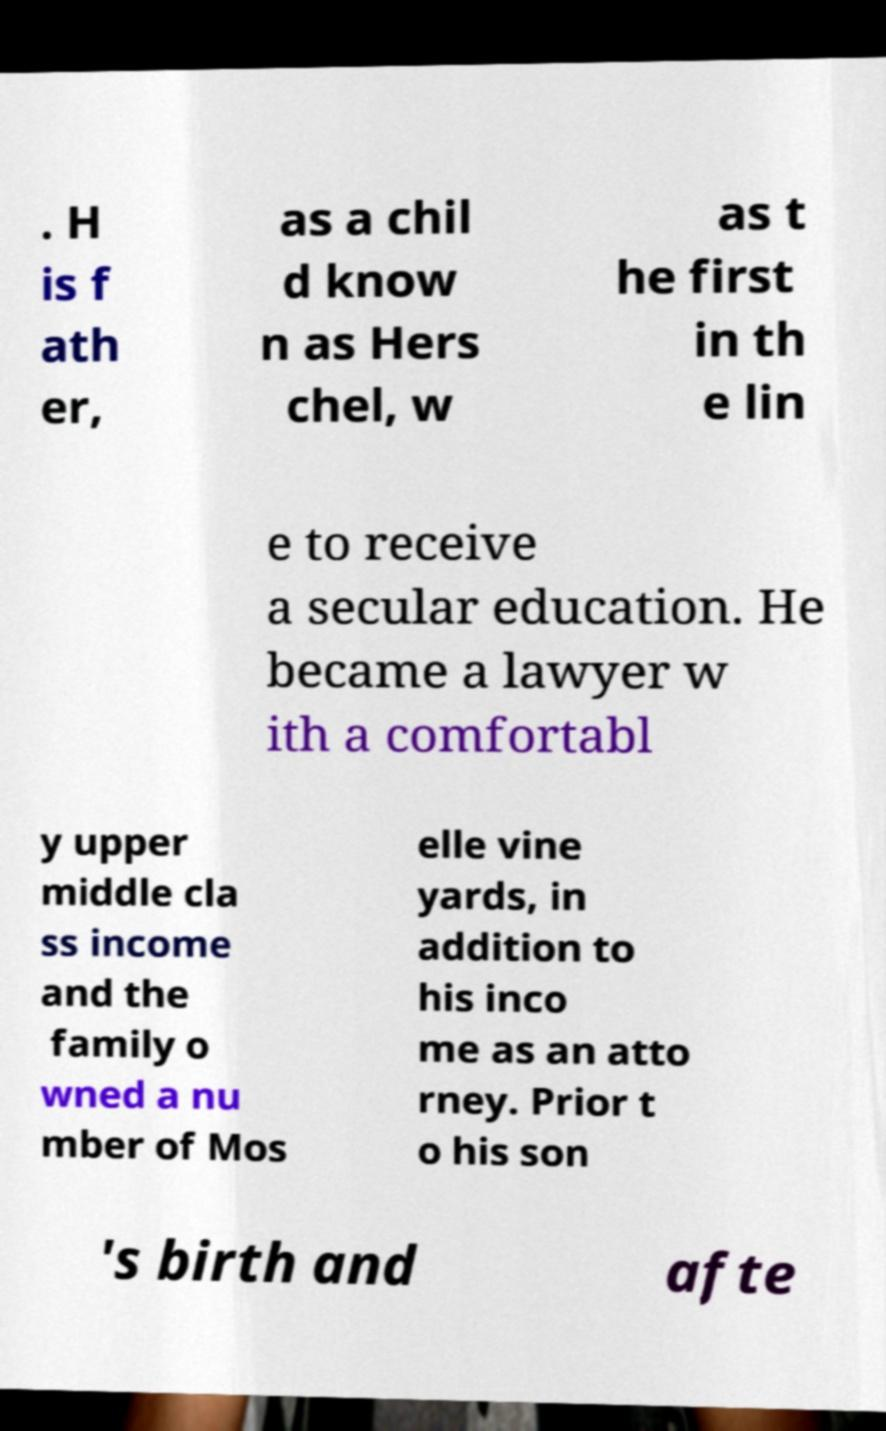Can you read and provide the text displayed in the image?This photo seems to have some interesting text. Can you extract and type it out for me? . H is f ath er, as a chil d know n as Hers chel, w as t he first in th e lin e to receive a secular education. He became a lawyer w ith a comfortabl y upper middle cla ss income and the family o wned a nu mber of Mos elle vine yards, in addition to his inco me as an atto rney. Prior t o his son 's birth and afte 